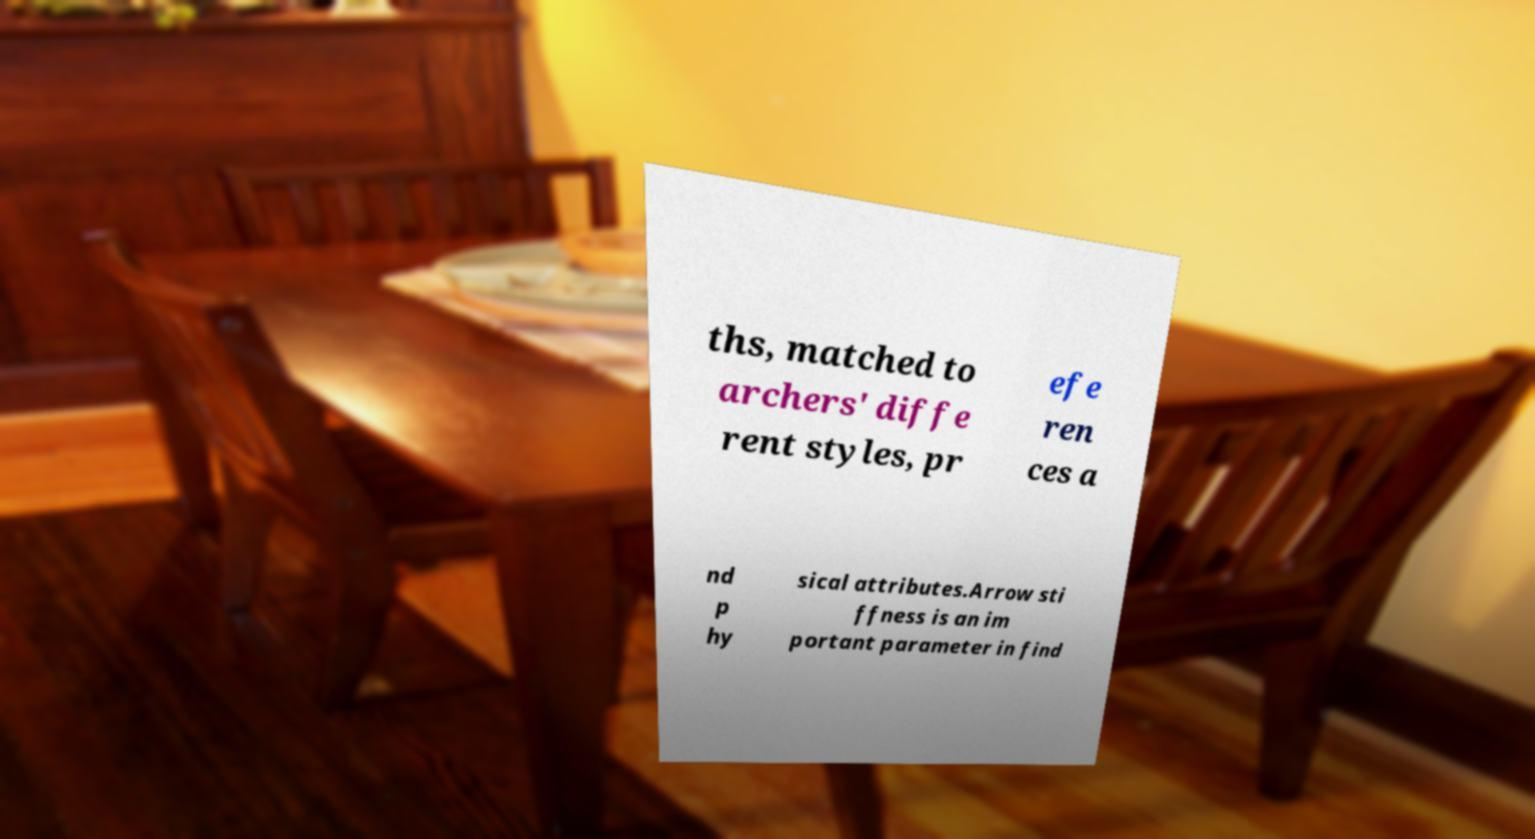Can you read and provide the text displayed in the image?This photo seems to have some interesting text. Can you extract and type it out for me? ths, matched to archers' diffe rent styles, pr efe ren ces a nd p hy sical attributes.Arrow sti ffness is an im portant parameter in find 